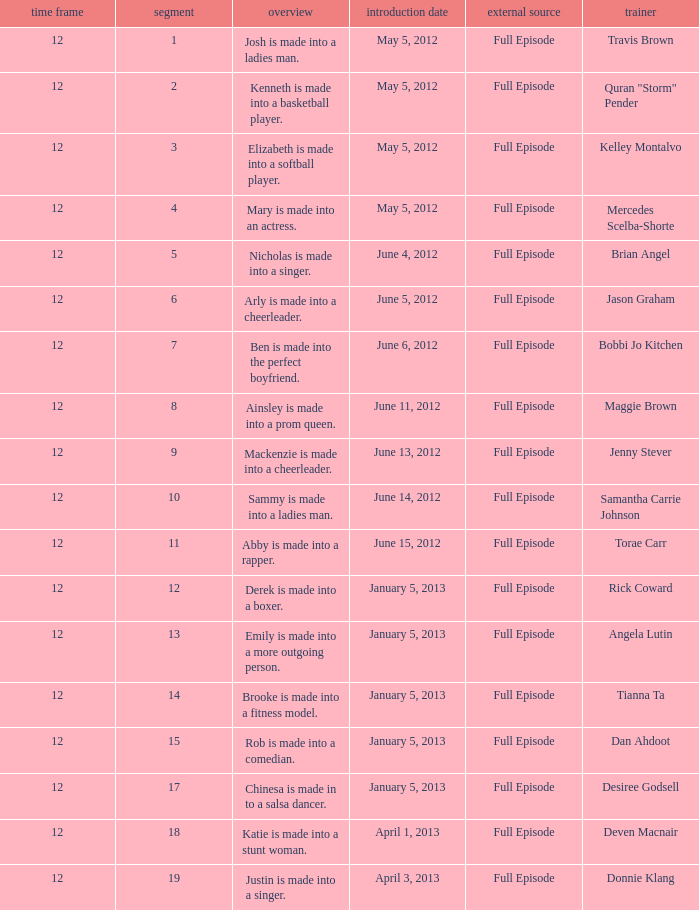Name the episode for travis brown 1.0. 